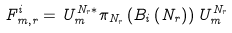Convert formula to latex. <formula><loc_0><loc_0><loc_500><loc_500>F _ { m , r } ^ { i } = U _ { m } ^ { N _ { r } \ast } \pi _ { N _ { r } } \left ( B _ { i } \left ( N _ { r } \right ) \right ) U _ { m } ^ { N _ { r } }</formula> 